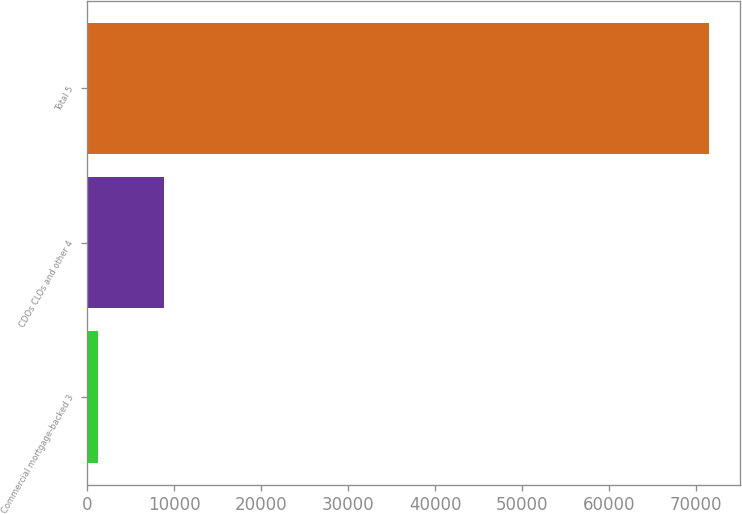Convert chart to OTSL. <chart><loc_0><loc_0><loc_500><loc_500><bar_chart><fcel>Commercial mortgage-backed 3<fcel>CDOs CLOs and other 4<fcel>Total 5<nl><fcel>1253<fcel>8866<fcel>71460<nl></chart> 